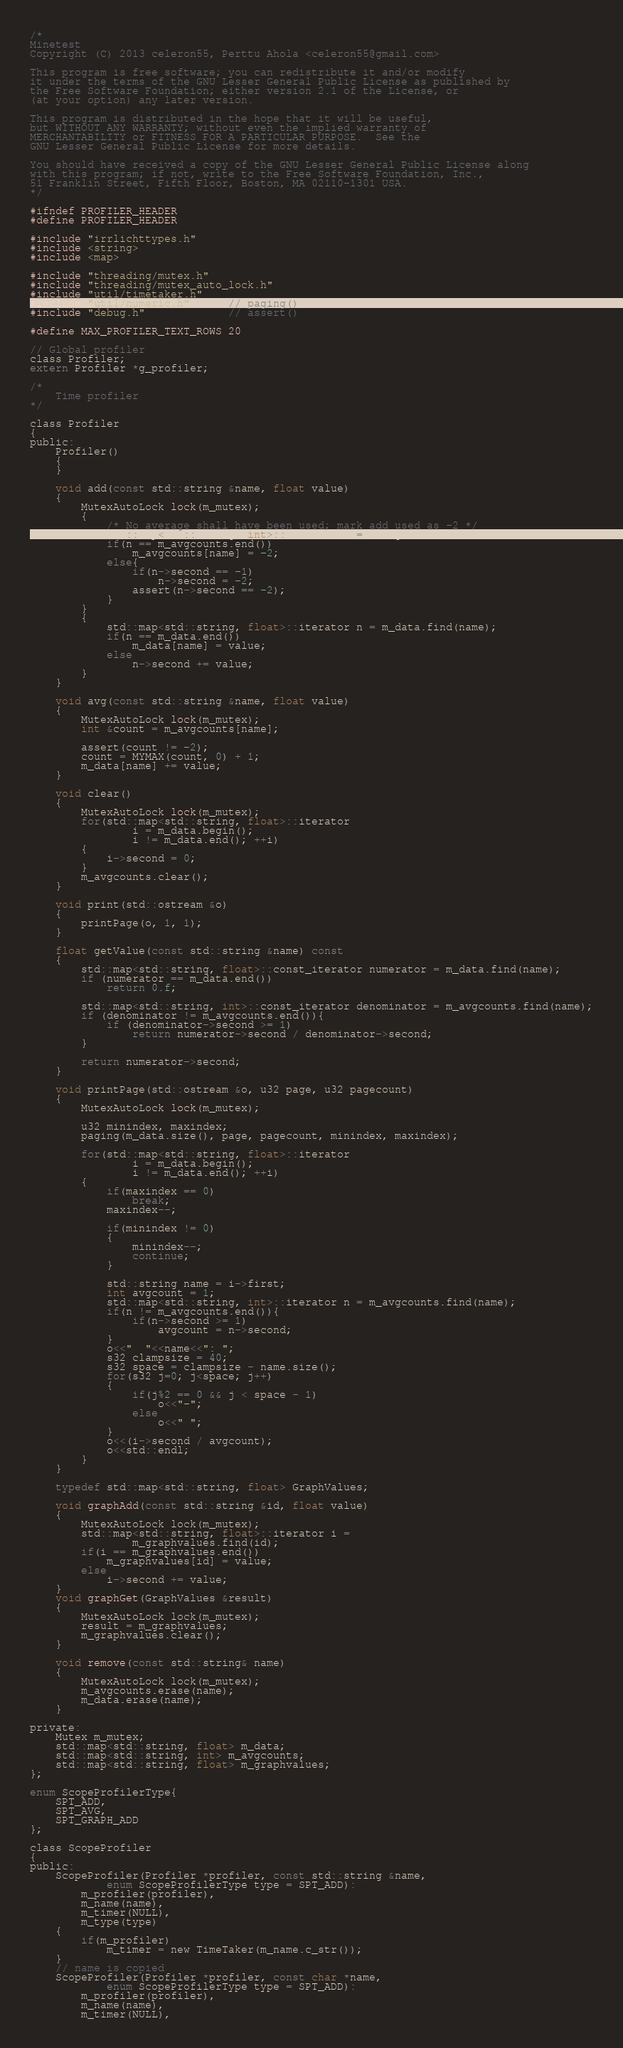<code> <loc_0><loc_0><loc_500><loc_500><_C_>/*
Minetest
Copyright (C) 2013 celeron55, Perttu Ahola <celeron55@gmail.com>

This program is free software; you can redistribute it and/or modify
it under the terms of the GNU Lesser General Public License as published by
the Free Software Foundation; either version 2.1 of the License, or
(at your option) any later version.

This program is distributed in the hope that it will be useful,
but WITHOUT ANY WARRANTY; without even the implied warranty of
MERCHANTABILITY or FITNESS FOR A PARTICULAR PURPOSE.  See the
GNU Lesser General Public License for more details.

You should have received a copy of the GNU Lesser General Public License along
with this program; if not, write to the Free Software Foundation, Inc.,
51 Franklin Street, Fifth Floor, Boston, MA 02110-1301 USA.
*/

#ifndef PROFILER_HEADER
#define PROFILER_HEADER

#include "irrlichttypes.h"
#include <string>
#include <map>

#include "threading/mutex.h"
#include "threading/mutex_auto_lock.h"
#include "util/timetaker.h"
#include "util/numeric.h"      // paging()
#include "debug.h"             // assert()

#define MAX_PROFILER_TEXT_ROWS 20

// Global profiler
class Profiler;
extern Profiler *g_profiler;

/*
	Time profiler
*/

class Profiler
{
public:
	Profiler()
	{
	}

	void add(const std::string &name, float value)
	{
		MutexAutoLock lock(m_mutex);
		{
			/* No average shall have been used; mark add used as -2 */
			std::map<std::string, int>::iterator n = m_avgcounts.find(name);
			if(n == m_avgcounts.end())
				m_avgcounts[name] = -2;
			else{
				if(n->second == -1)
					n->second = -2;
				assert(n->second == -2);
			}
		}
		{
			std::map<std::string, float>::iterator n = m_data.find(name);
			if(n == m_data.end())
				m_data[name] = value;
			else
				n->second += value;
		}
	}

	void avg(const std::string &name, float value)
	{
		MutexAutoLock lock(m_mutex);
		int &count = m_avgcounts[name];

		assert(count != -2);
		count = MYMAX(count, 0) + 1;
		m_data[name] += value;
	}

	void clear()
	{
		MutexAutoLock lock(m_mutex);
		for(std::map<std::string, float>::iterator
				i = m_data.begin();
				i != m_data.end(); ++i)
		{
			i->second = 0;
		}
		m_avgcounts.clear();
	}

	void print(std::ostream &o)
	{
		printPage(o, 1, 1);
	}

	float getValue(const std::string &name) const
	{
		std::map<std::string, float>::const_iterator numerator = m_data.find(name);
		if (numerator == m_data.end())
			return 0.f;

		std::map<std::string, int>::const_iterator denominator = m_avgcounts.find(name);
		if (denominator != m_avgcounts.end()){
			if (denominator->second >= 1)
				return numerator->second / denominator->second;
		}

		return numerator->second;
	}

	void printPage(std::ostream &o, u32 page, u32 pagecount)
	{
		MutexAutoLock lock(m_mutex);

		u32 minindex, maxindex;
		paging(m_data.size(), page, pagecount, minindex, maxindex);

		for(std::map<std::string, float>::iterator
				i = m_data.begin();
				i != m_data.end(); ++i)
		{
			if(maxindex == 0)
				break;
			maxindex--;

			if(minindex != 0)
			{
				minindex--;
				continue;
			}

			std::string name = i->first;
			int avgcount = 1;
			std::map<std::string, int>::iterator n = m_avgcounts.find(name);
			if(n != m_avgcounts.end()){
				if(n->second >= 1)
					avgcount = n->second;
			}
			o<<"  "<<name<<": ";
			s32 clampsize = 40;
			s32 space = clampsize - name.size();
			for(s32 j=0; j<space; j++)
			{
				if(j%2 == 0 && j < space - 1)
					o<<"-";
				else
					o<<" ";
			}
			o<<(i->second / avgcount);
			o<<std::endl;
		}
	}

	typedef std::map<std::string, float> GraphValues;

	void graphAdd(const std::string &id, float value)
	{
		MutexAutoLock lock(m_mutex);
		std::map<std::string, float>::iterator i =
				m_graphvalues.find(id);
		if(i == m_graphvalues.end())
			m_graphvalues[id] = value;
		else
			i->second += value;
	}
	void graphGet(GraphValues &result)
	{
		MutexAutoLock lock(m_mutex);
		result = m_graphvalues;
		m_graphvalues.clear();
	}

	void remove(const std::string& name)
	{
		MutexAutoLock lock(m_mutex);
		m_avgcounts.erase(name);
		m_data.erase(name);
	}

private:
	Mutex m_mutex;
	std::map<std::string, float> m_data;
	std::map<std::string, int> m_avgcounts;
	std::map<std::string, float> m_graphvalues;
};

enum ScopeProfilerType{
	SPT_ADD,
	SPT_AVG,
	SPT_GRAPH_ADD
};

class ScopeProfiler
{
public:
	ScopeProfiler(Profiler *profiler, const std::string &name,
			enum ScopeProfilerType type = SPT_ADD):
		m_profiler(profiler),
		m_name(name),
		m_timer(NULL),
		m_type(type)
	{
		if(m_profiler)
			m_timer = new TimeTaker(m_name.c_str());
	}
	// name is copied
	ScopeProfiler(Profiler *profiler, const char *name,
			enum ScopeProfilerType type = SPT_ADD):
		m_profiler(profiler),
		m_name(name),
		m_timer(NULL),</code> 